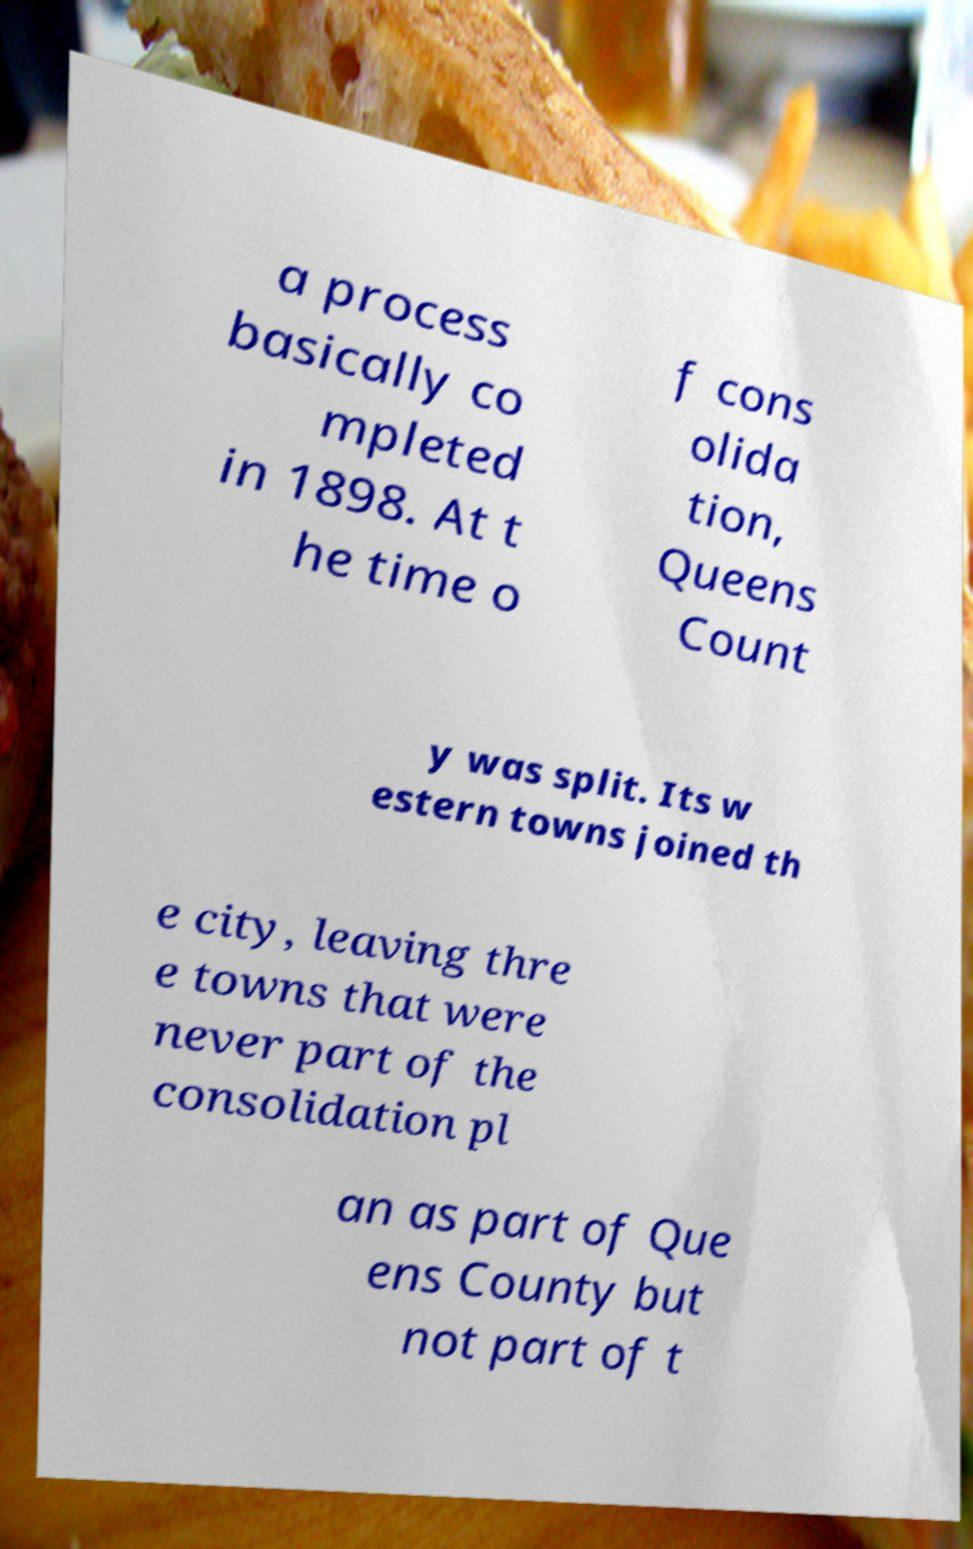Please read and relay the text visible in this image. What does it say? a process basically co mpleted in 1898. At t he time o f cons olida tion, Queens Count y was split. Its w estern towns joined th e city, leaving thre e towns that were never part of the consolidation pl an as part of Que ens County but not part of t 